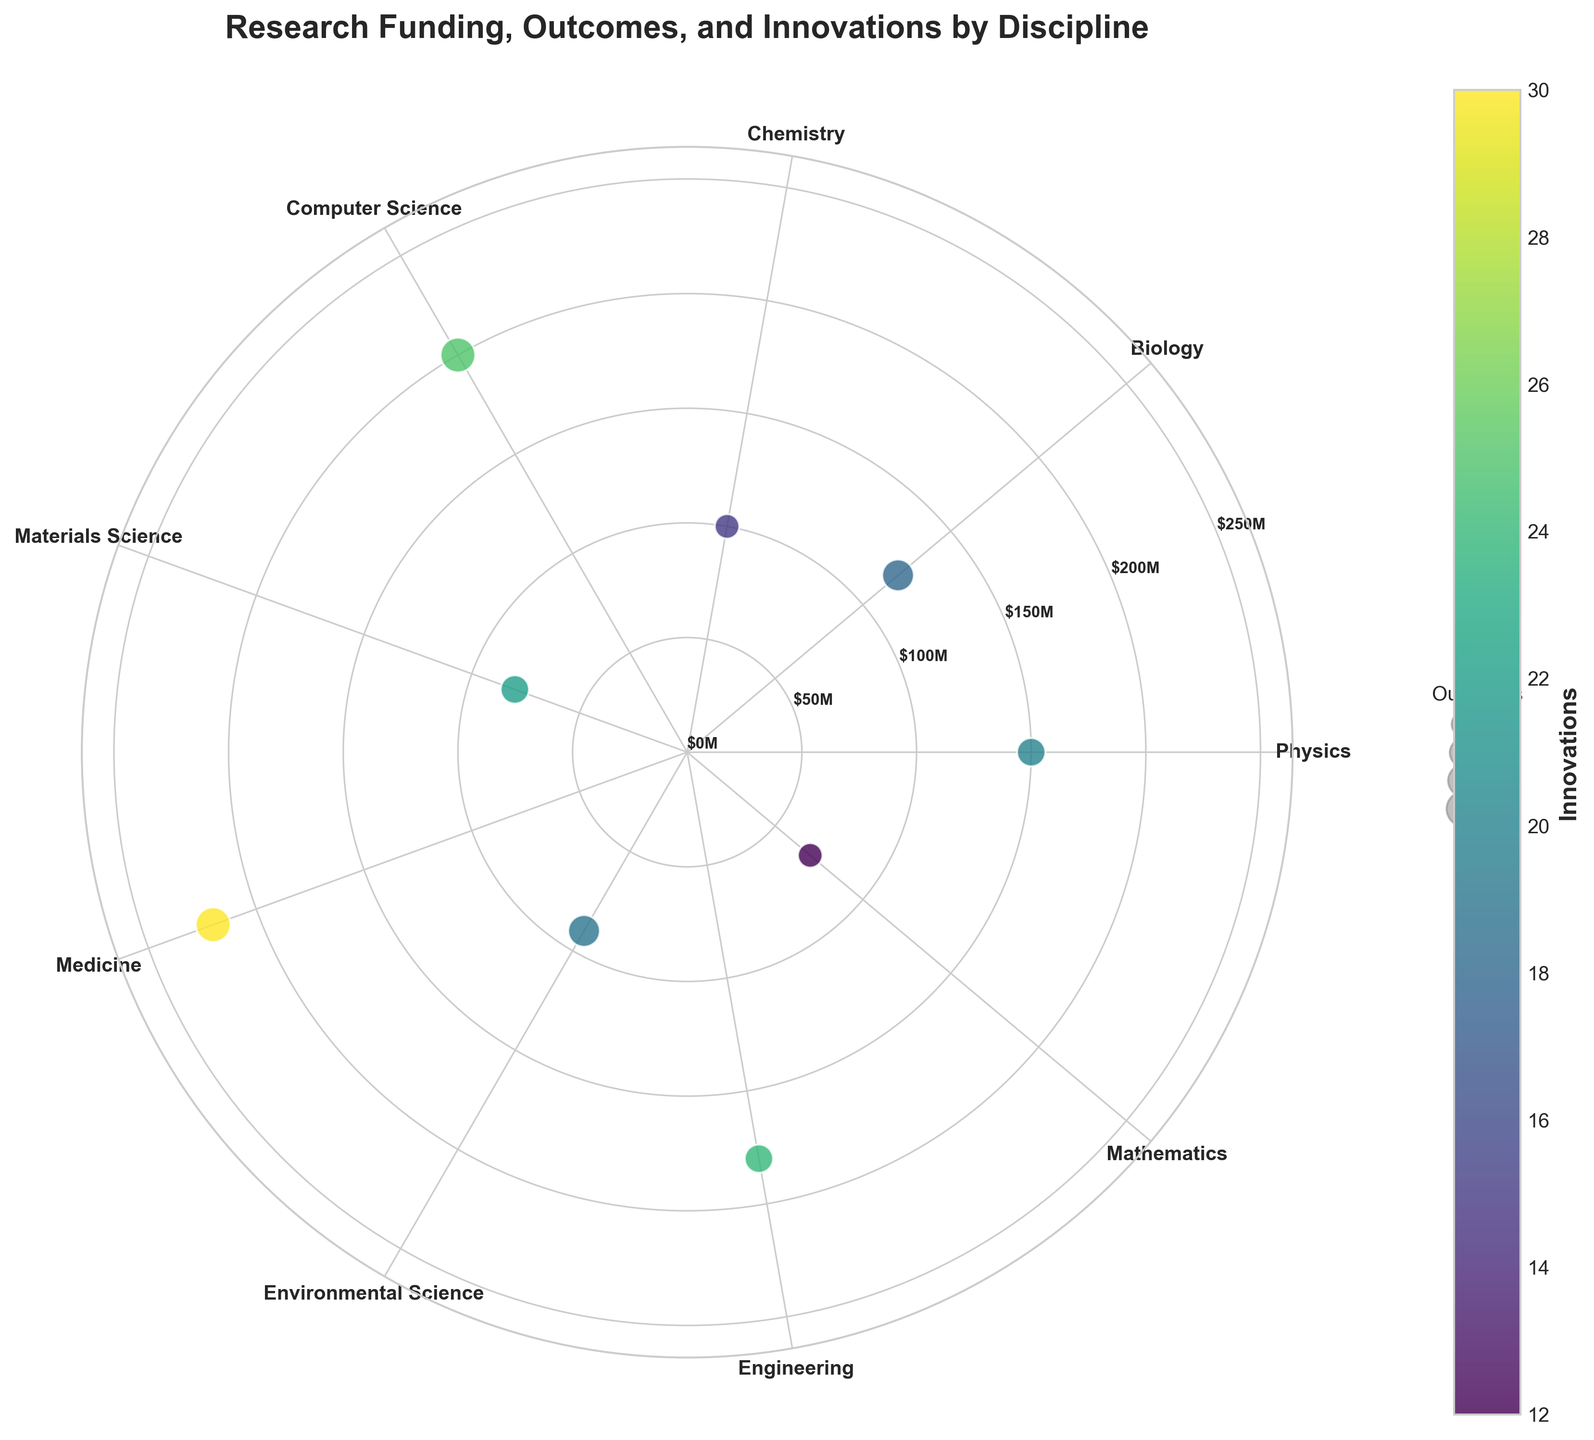Which discipline received the highest funding? The highest points lie at the top of the radial axis. The discipline placed closest to the maximum funding value is Medicine.
Answer: Medicine How many disciplines are represented in the chart? The chart has labeled points arranged axially. Counting them, there are 9 labeled disciplines.
Answer: 9 What is the title of the chart? The chart's title is positioned above the plot. It reads 'Research Funding, Outcomes, and Innovations by Discipline'.
Answer: Research Funding, Outcomes, and Innovations by Discipline Which discipline has the highest number of innovations? The color bar on the side indicates that darker colors represent a higher number of innovations. Medicine has the darkest point on the chart.
Answer: Medicine What is the discipline with the least amount of funding? The lowest funding is at the inner radial axis. Mathematics is closest to the center.
Answer: Mathematics Which discipline has the most favorable combination of funding, outcomes, and innovations? Medicine stands out with the highest funding, significant outcomes, and highest innovations as indicated by larger and darker points near the upper radial axis.
Answer: Medicine Compare the funding between Engineering and Biology. Which one has more? Engineering's point is further from the center compared to Biology, indicating higher funding.
Answer: Engineering What is the color representing Chemistry on the scatter plot? Chemistry has a specific spot marked by its label, represented with a lighter shade. Relative to others, it is a light green color.
Answer: Light green How many disciplines have outcomes rated at 6? The legend for outcomes indicates the size of points. Checking the plot, there are two larger-sized points, belonging to Medicine and Computer Science.
Answer: 2 Which discipline has higher innovations, Physics or Material Science? Checking for the color that represents innovations, Materials Science displays a darker color compared to Physics.
Answer: Materials Science 